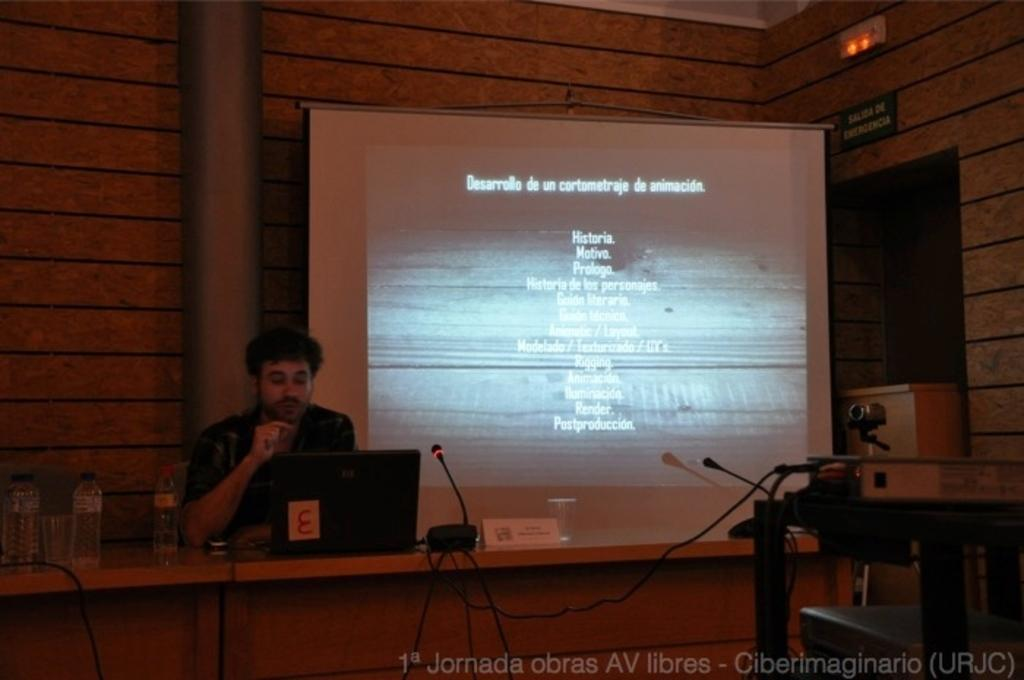What is the man in the image doing? There is a man sitting in the image. What is in front of the man? There is a table in front of the man. What can be seen on the table? There is a "my" (possibly a typo for "mug"), a bottle, and a glass on the table. What is visible in the background of the image? There is a screen, a wall, and a pillar in the background of the image. Can you see any steam coming from the mug in the image? There is no mug present in the image, only a "my" (possibly a typo for "mug"). Additionally, there is no steam visible in the image. 